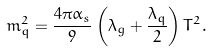<formula> <loc_0><loc_0><loc_500><loc_500>m _ { q } ^ { 2 } = \frac { 4 \pi \alpha _ { s } } { 9 } \left ( \lambda _ { g } + \frac { \lambda _ { q } } { 2 } \right ) T ^ { 2 } .</formula> 